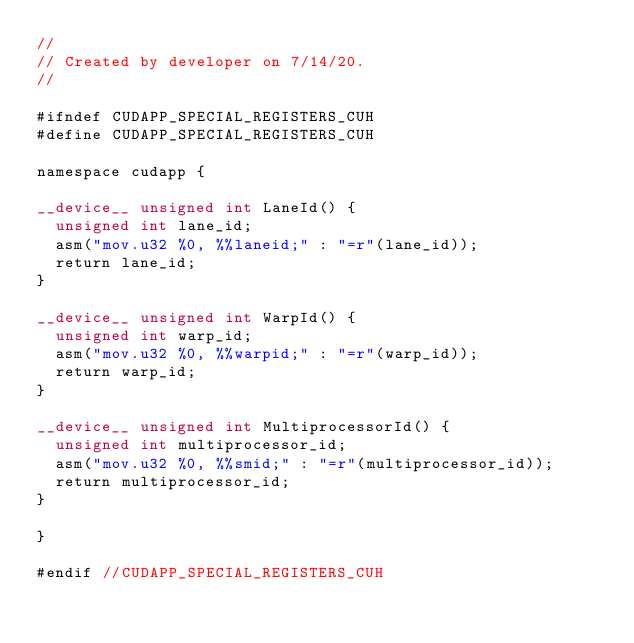<code> <loc_0><loc_0><loc_500><loc_500><_Cuda_>//
// Created by developer on 7/14/20.
//

#ifndef CUDAPP_SPECIAL_REGISTERS_CUH
#define CUDAPP_SPECIAL_REGISTERS_CUH

namespace cudapp {

__device__ unsigned int LaneId() {
  unsigned int lane_id;
  asm("mov.u32 %0, %%laneid;" : "=r"(lane_id));
  return lane_id;
}

__device__ unsigned int WarpId() {
  unsigned int warp_id;
  asm("mov.u32 %0, %%warpid;" : "=r"(warp_id));
  return warp_id;
}

__device__ unsigned int MultiprocessorId() {
  unsigned int multiprocessor_id;
  asm("mov.u32 %0, %%smid;" : "=r"(multiprocessor_id));
  return multiprocessor_id;
}

}

#endif //CUDAPP_SPECIAL_REGISTERS_CUH
</code> 